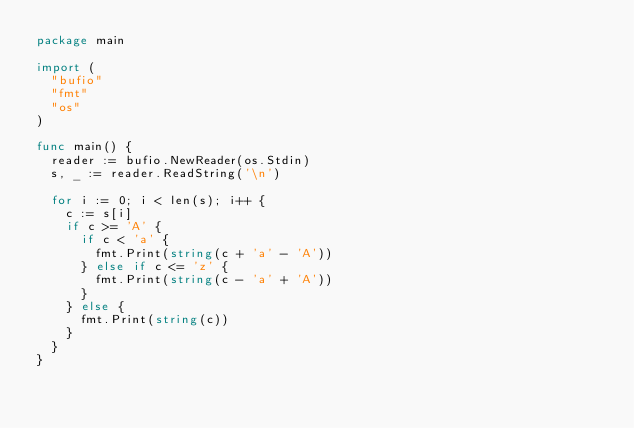Convert code to text. <code><loc_0><loc_0><loc_500><loc_500><_Go_>package main

import (
	"bufio"
	"fmt"
	"os"
)

func main() {
	reader := bufio.NewReader(os.Stdin)
	s, _ := reader.ReadString('\n')

	for i := 0; i < len(s); i++ {
		c := s[i]
		if c >= 'A' {
			if c < 'a' {
				fmt.Print(string(c + 'a' - 'A'))
			} else if c <= 'z' {
				fmt.Print(string(c - 'a' + 'A'))
			}
		} else {
			fmt.Print(string(c))
		}
	}
}

</code> 